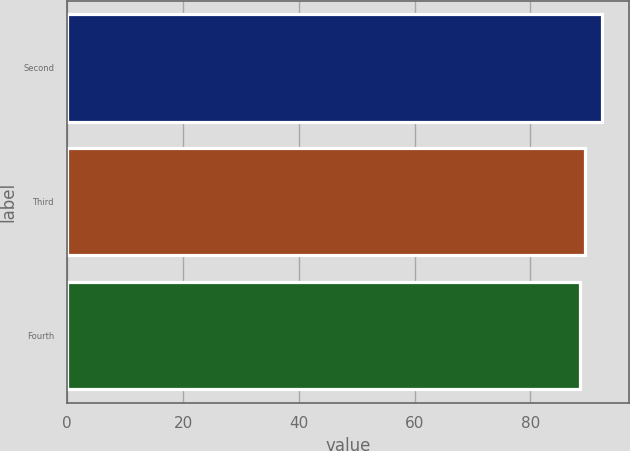<chart> <loc_0><loc_0><loc_500><loc_500><bar_chart><fcel>Second<fcel>Third<fcel>Fourth<nl><fcel>92.34<fcel>89.4<fcel>88.49<nl></chart> 